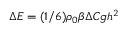<formula> <loc_0><loc_0><loc_500><loc_500>\Delta E = ( 1 / 6 ) \rho _ { 0 } \beta \Delta C g h ^ { 2 }</formula> 